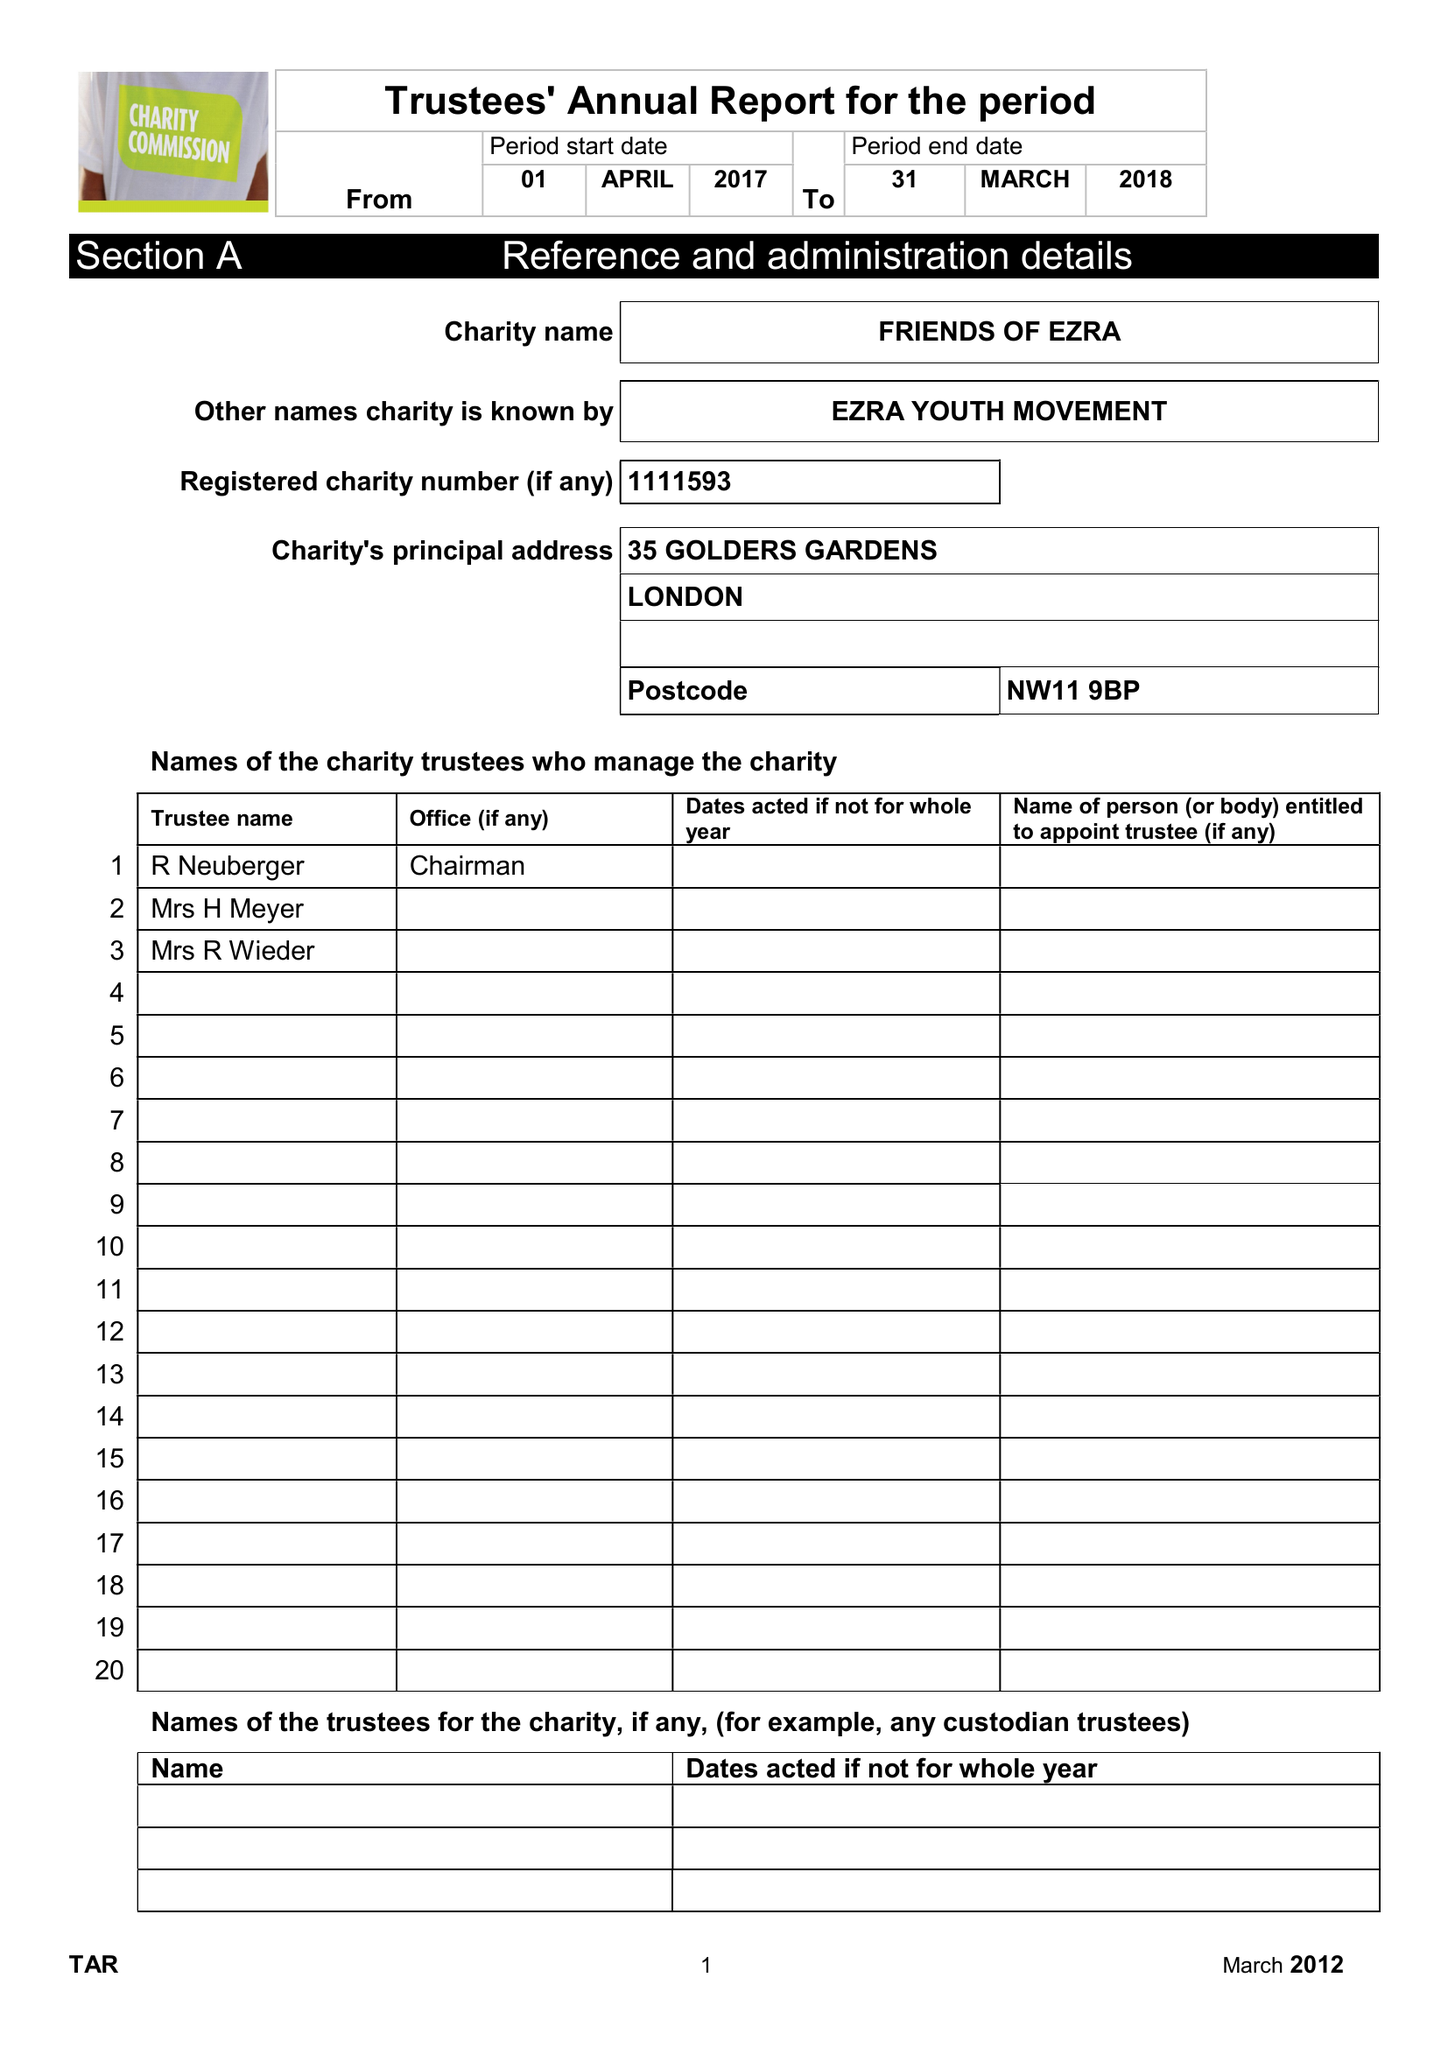What is the value for the charity_name?
Answer the question using a single word or phrase. Friends Of Ezra 